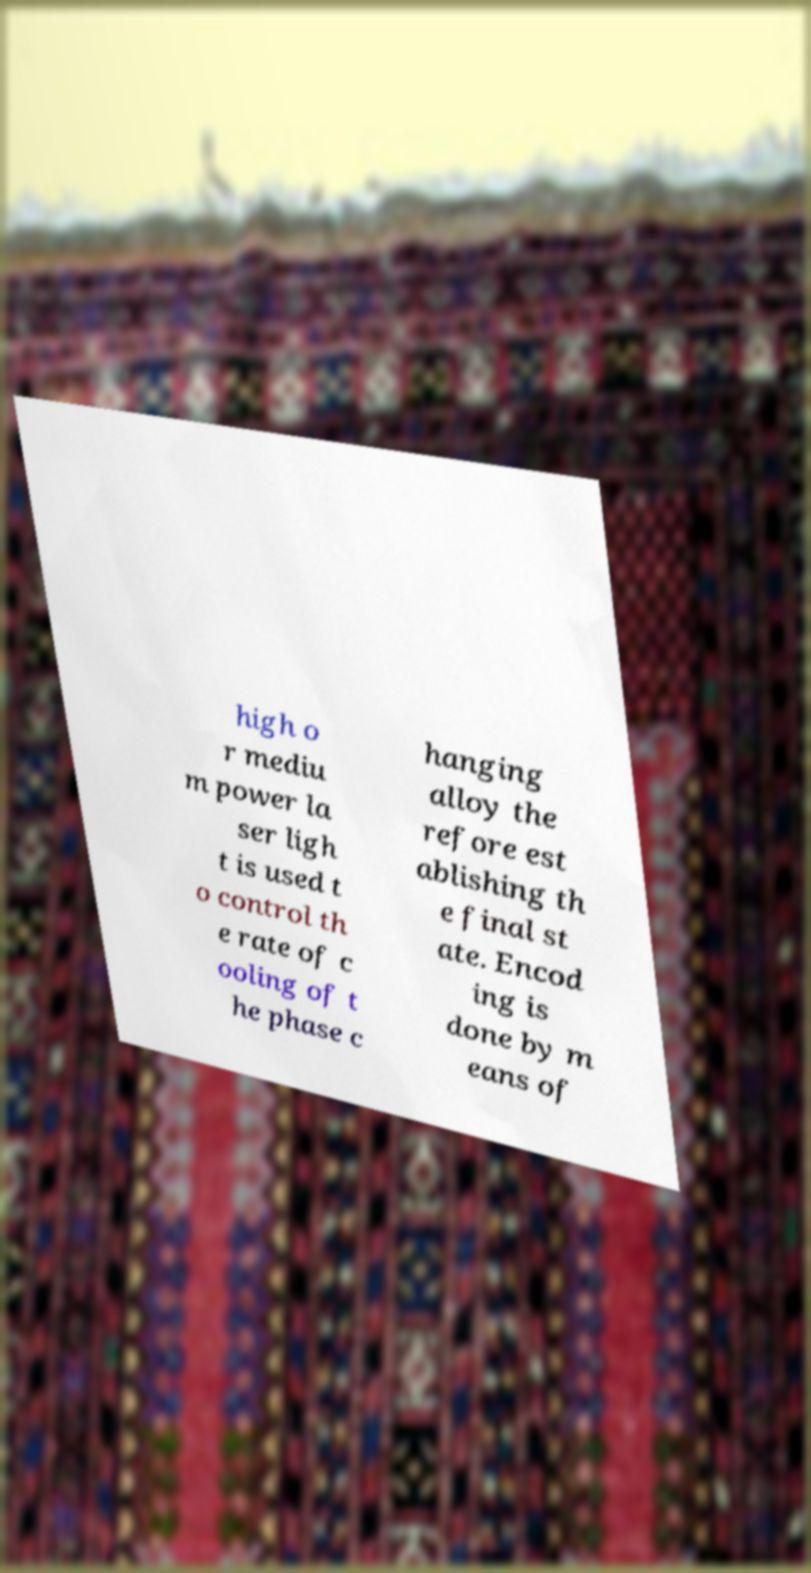Could you assist in decoding the text presented in this image and type it out clearly? high o r mediu m power la ser ligh t is used t o control th e rate of c ooling of t he phase c hanging alloy the refore est ablishing th e final st ate. Encod ing is done by m eans of 